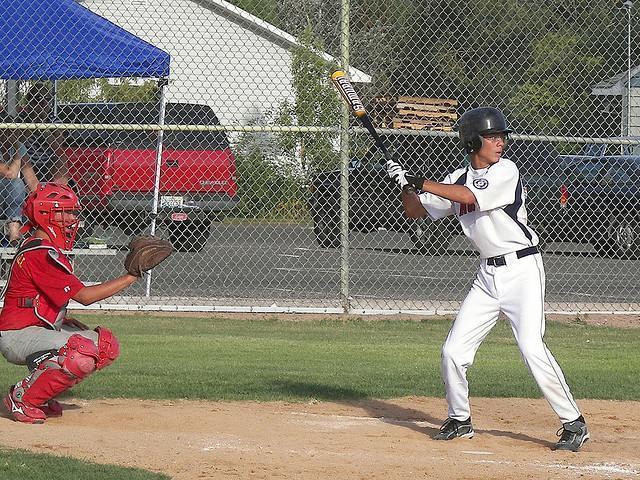Why is he holding the bat behind him?
Indicate the correct choice and explain in the format: 'Answer: answer
Rationale: rationale.'
Options: Intimidate others, lost bet, novice, hit ball. Answer: hit ball.
Rationale: He is ready to swing when the ball comes 